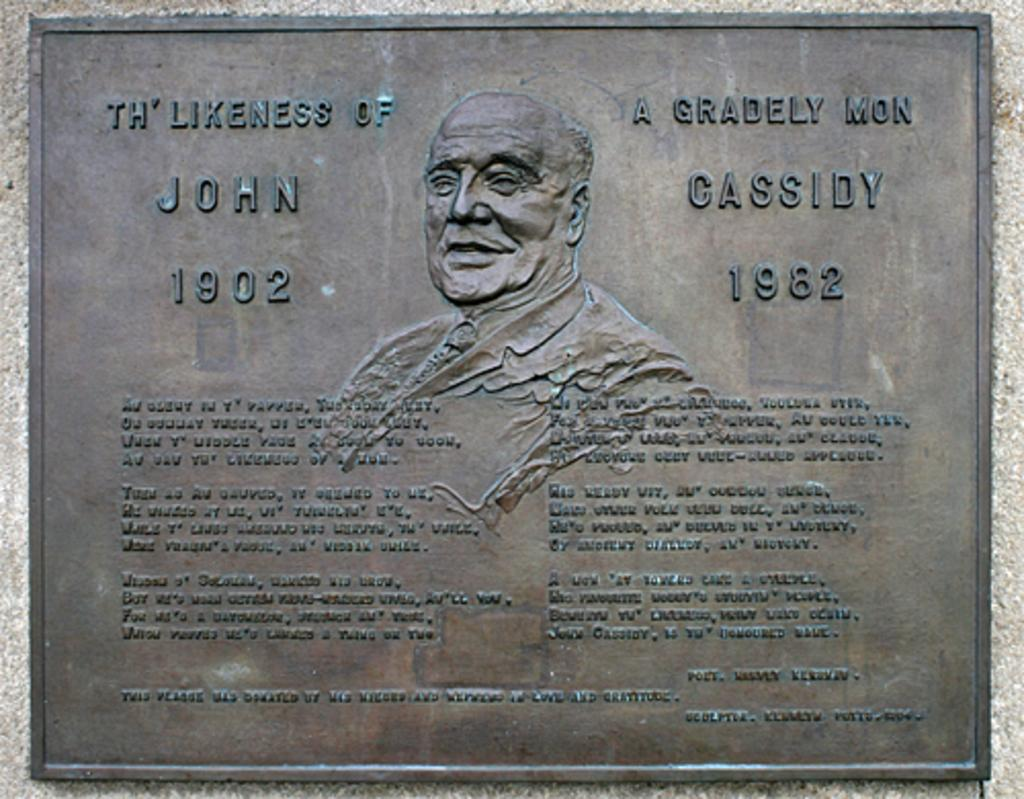What is the main subject of the image? The main subject of the image is a statue of a person. What can be seen on the statue? There is text on the statue. Can you describe the island that the statue is standing on in the image? There is no island present in the image; the statue is not standing on an island. What type of ball is being used by the statue in the image? There is no ball present in the image; the statue is not interacting with a ball. 